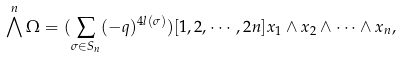<formula> <loc_0><loc_0><loc_500><loc_500>\bigwedge ^ { n } \Omega = ( \sum _ { \sigma \in S _ { n } } ( - q ) ^ { 4 l ( \sigma ) } ) [ 1 , 2 , \cdots , 2 n ] x _ { 1 } \wedge x _ { 2 } \wedge \cdots \wedge x _ { n } ,</formula> 